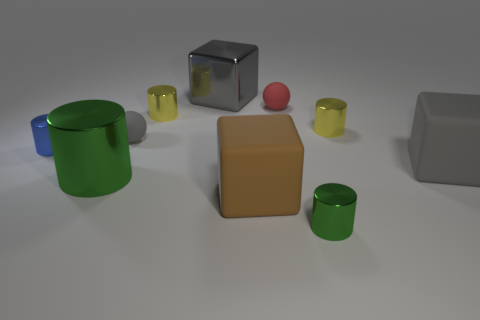Subtract all tiny cylinders. How many cylinders are left? 1 Subtract 2 balls. How many balls are left? 0 Subtract all brown blocks. How many blocks are left? 2 Subtract all spheres. How many objects are left? 8 Subtract all gray spheres. Subtract all cyan cylinders. How many spheres are left? 1 Subtract all gray cubes. How many green cylinders are left? 2 Subtract all purple rubber cubes. Subtract all tiny things. How many objects are left? 4 Add 7 big gray metal things. How many big gray metal things are left? 8 Add 3 small green cylinders. How many small green cylinders exist? 4 Subtract 0 red cylinders. How many objects are left? 10 